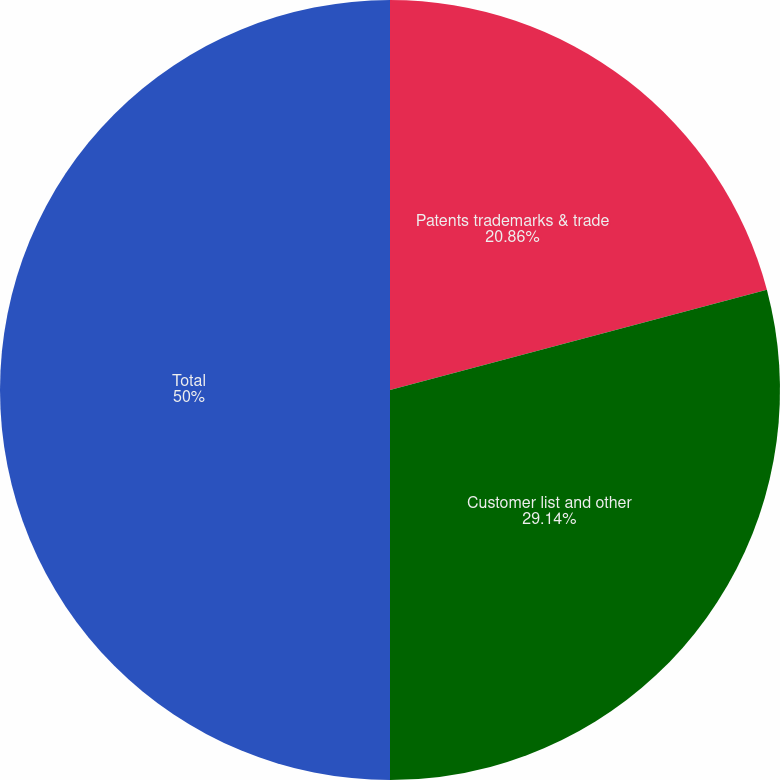<chart> <loc_0><loc_0><loc_500><loc_500><pie_chart><fcel>Patents trademarks & trade<fcel>Customer list and other<fcel>Total<nl><fcel>20.86%<fcel>29.14%<fcel>50.0%<nl></chart> 